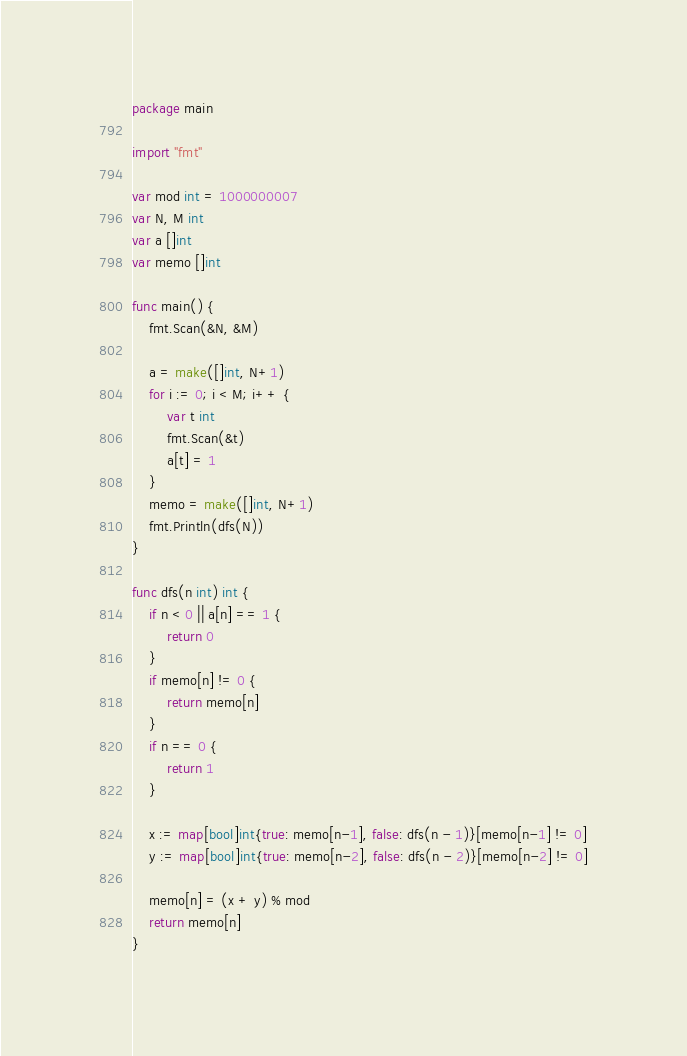<code> <loc_0><loc_0><loc_500><loc_500><_Go_>package main

import "fmt"

var mod int = 1000000007
var N, M int
var a []int
var memo []int

func main() {
	fmt.Scan(&N, &M)

	a = make([]int, N+1)
	for i := 0; i < M; i++ {
		var t int
		fmt.Scan(&t)
		a[t] = 1
	}
	memo = make([]int, N+1)
	fmt.Println(dfs(N))
}

func dfs(n int) int {
	if n < 0 || a[n] == 1 {
		return 0
	}
	if memo[n] != 0 {
		return memo[n]
	}
	if n == 0 {
		return 1
	}

	x := map[bool]int{true: memo[n-1], false: dfs(n - 1)}[memo[n-1] != 0]
	y := map[bool]int{true: memo[n-2], false: dfs(n - 2)}[memo[n-2] != 0]

	memo[n] = (x + y) % mod
	return memo[n]
}
</code> 